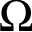Convert formula to latex. <formula><loc_0><loc_0><loc_500><loc_500>\Omega</formula> 